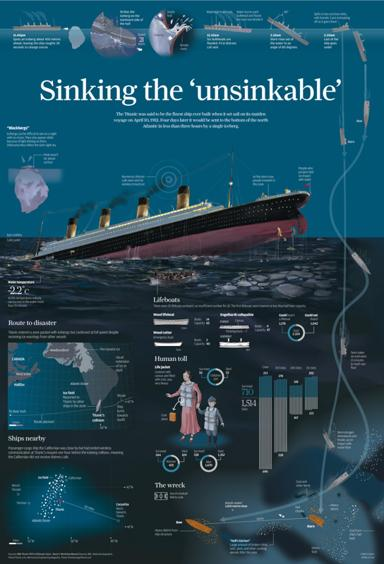What type of visual representation is depicted in the image? The image is an infographic that consolidates detailed information about the Titanic's voyage, its tragic sinking, and the resulting implications. It includes timelines, key facts, statistical data, and diagrams to present a comprehensive view of the historical event. 